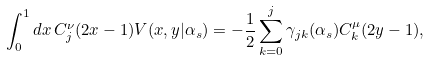<formula> <loc_0><loc_0><loc_500><loc_500>\int _ { 0 } ^ { 1 } d x \, C ^ { \nu } _ { j } ( 2 x - 1 ) V ( x , y | \alpha _ { s } ) = - \frac { 1 } { 2 } \sum _ { k = 0 } ^ { j } \gamma _ { j k } ( \alpha _ { s } ) C ^ { \mu } _ { k } ( 2 y - 1 ) ,</formula> 